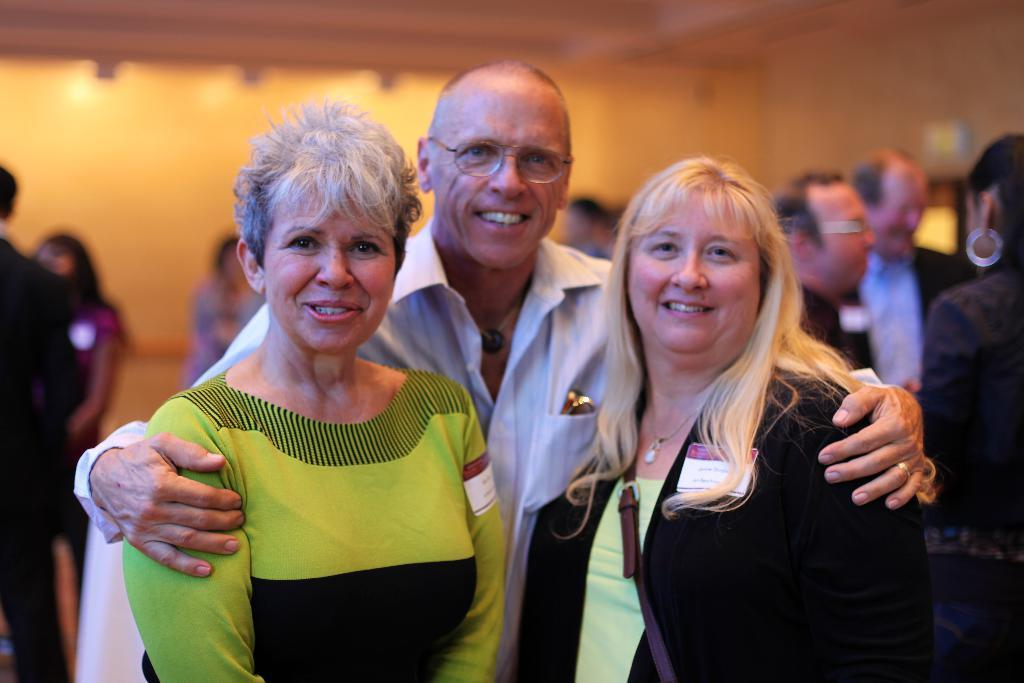How many people are in the foreground of the image? There are three persons standing in the foreground of the image. What are the expressions of the people in the foreground? The three persons in the foreground are smiling. Can you describe the attire of one of the persons in the foreground? One person in the foreground is wearing a handbag. What can be seen in the background of the image? There is a group of people and a wall in the background of the image. What type of boot is being used by the person in the image? There is no boot visible in the image; the person in the foreground is wearing a handbag. How many birds are flying in the image? There are no birds present in the image. 